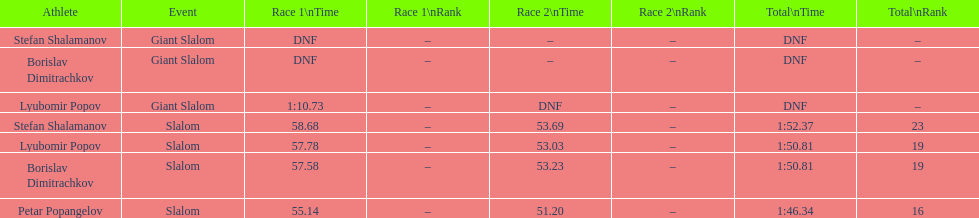How long did it take for lyubomir popov to finish the giant slalom in race 1? 1:10.73. 